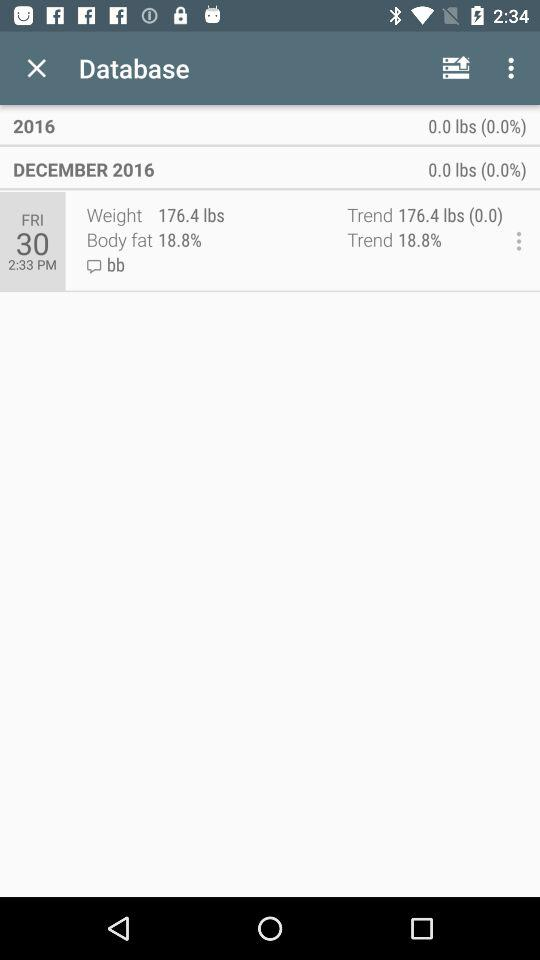What is the body fat percentage?
Answer the question using a single word or phrase. 18.8% 